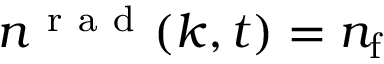Convert formula to latex. <formula><loc_0><loc_0><loc_500><loc_500>n ^ { r a d } ( k , t ) = n _ { f }</formula> 